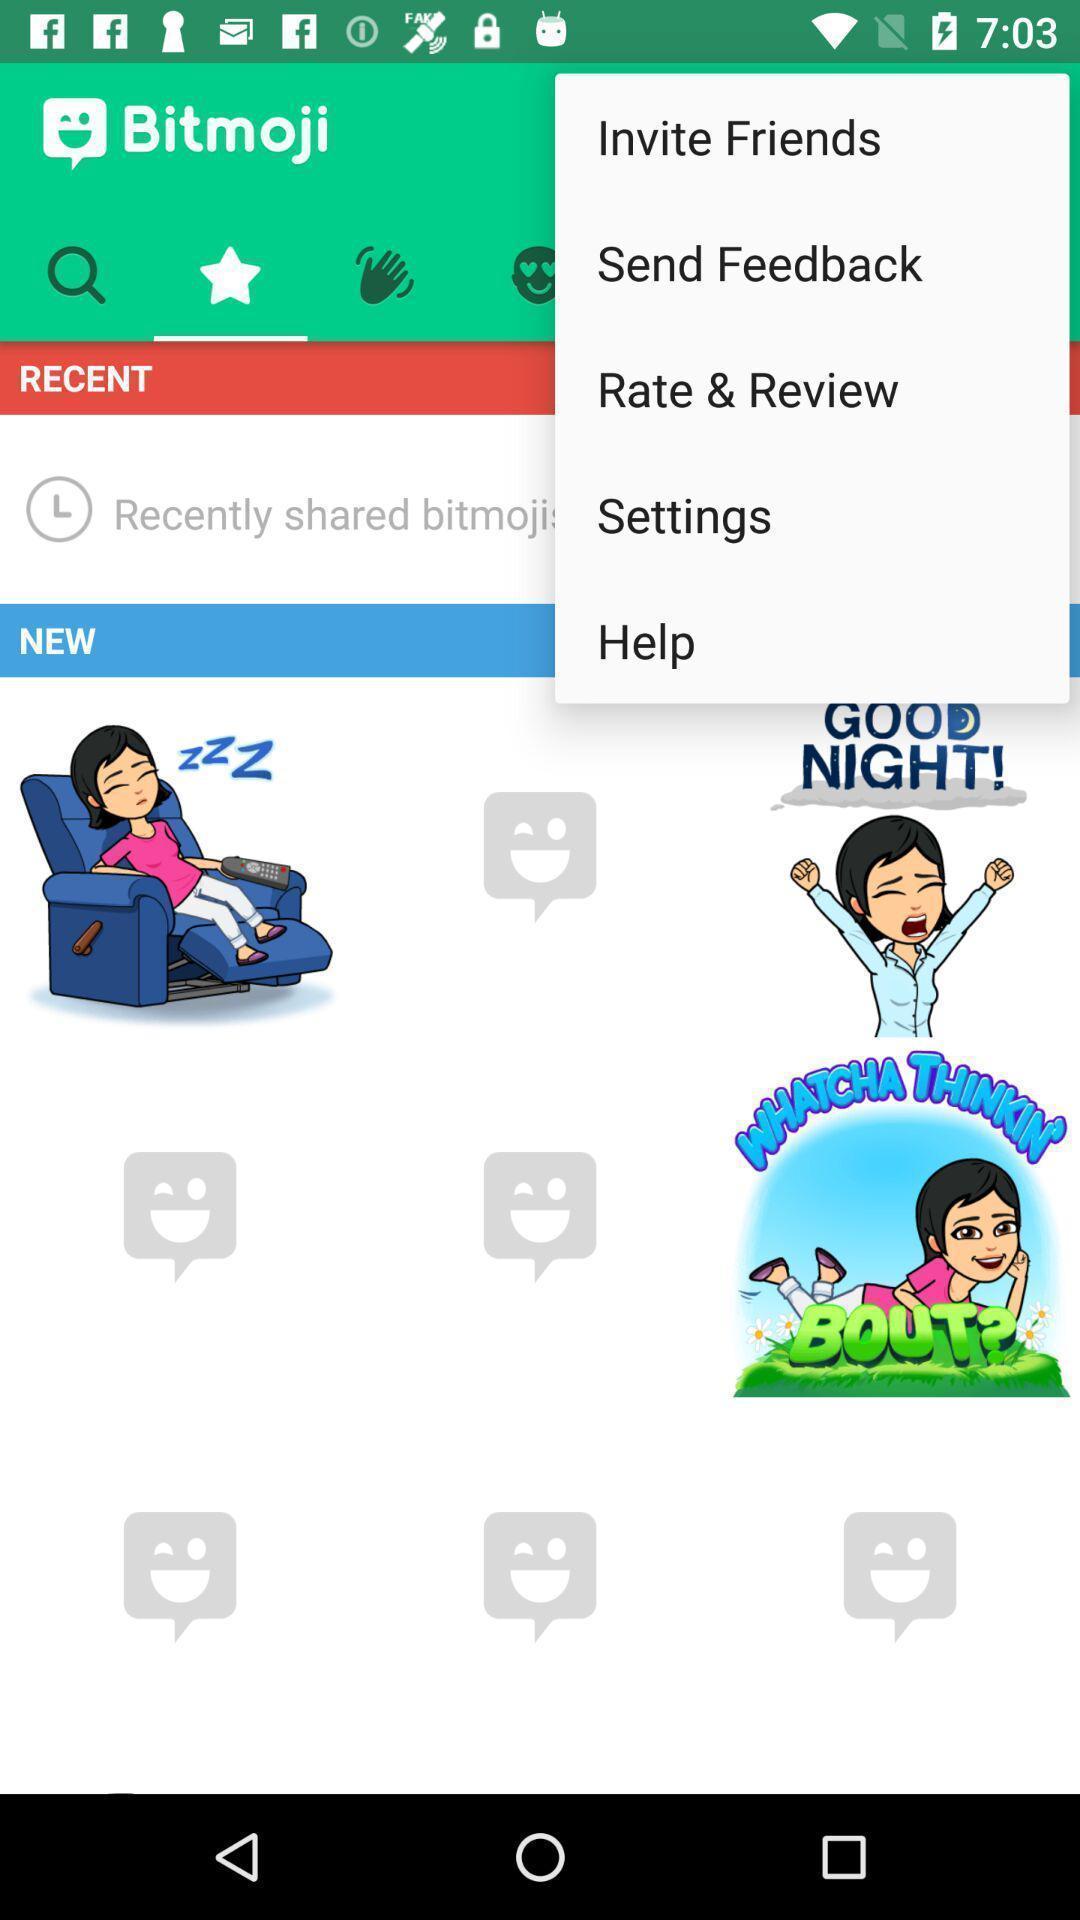Describe the content in this image. Screen shows options. 